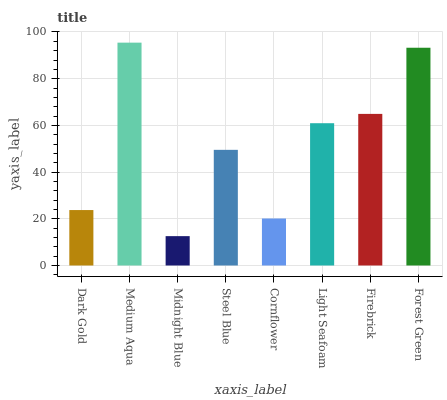Is Midnight Blue the minimum?
Answer yes or no. Yes. Is Medium Aqua the maximum?
Answer yes or no. Yes. Is Medium Aqua the minimum?
Answer yes or no. No. Is Midnight Blue the maximum?
Answer yes or no. No. Is Medium Aqua greater than Midnight Blue?
Answer yes or no. Yes. Is Midnight Blue less than Medium Aqua?
Answer yes or no. Yes. Is Midnight Blue greater than Medium Aqua?
Answer yes or no. No. Is Medium Aqua less than Midnight Blue?
Answer yes or no. No. Is Light Seafoam the high median?
Answer yes or no. Yes. Is Steel Blue the low median?
Answer yes or no. Yes. Is Forest Green the high median?
Answer yes or no. No. Is Dark Gold the low median?
Answer yes or no. No. 